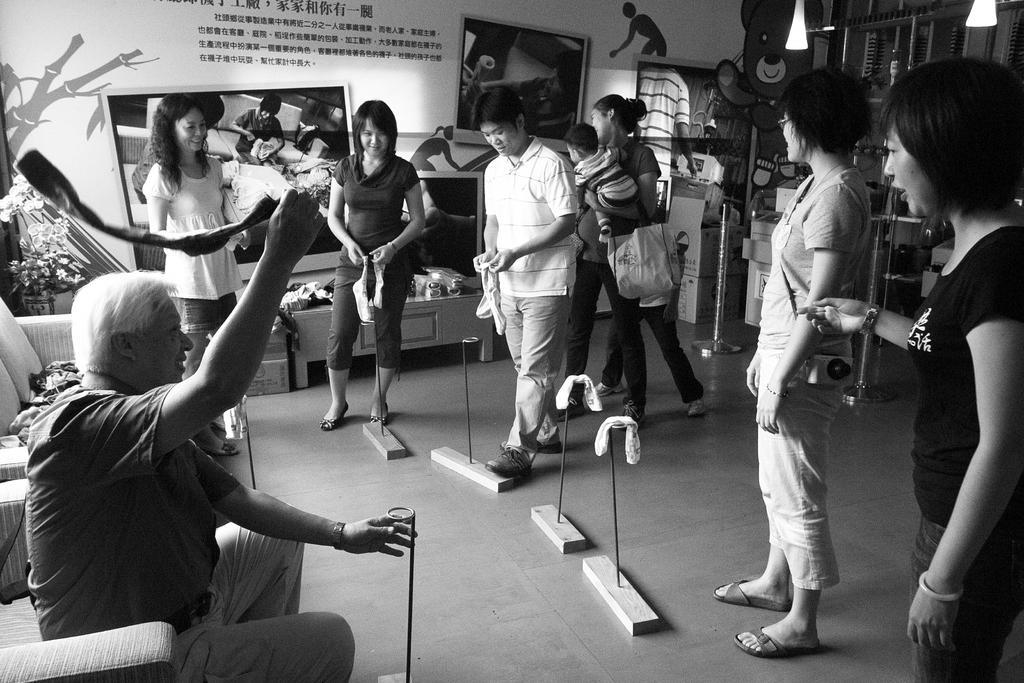Describe this image in one or two sentences. I see this is a black and white image and I see few people and I see this man is sitting on chair and I see few things on this floor and in the background I see the wall and I see words written over here and I can also see art on the wall and I see the poles over here. 